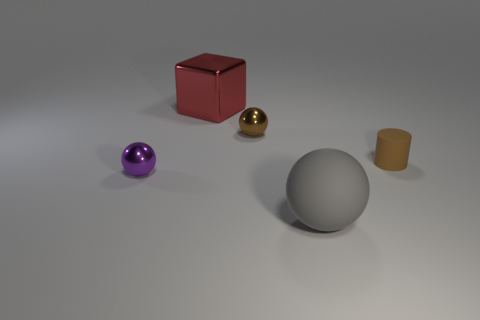There is a small shiny ball to the right of the red cube; does it have the same color as the small rubber object?
Your response must be concise. Yes. Do the cylinder and the small object that is behind the tiny brown cylinder have the same color?
Make the answer very short. Yes. What is the material of the purple sphere that is the same size as the brown cylinder?
Offer a very short reply. Metal. What number of objects are big things left of the brown ball or large brown blocks?
Give a very brief answer. 1. Is the number of large rubber balls right of the gray object the same as the number of large gray things?
Make the answer very short. No. There is a tiny object that is both left of the cylinder and right of the purple metal thing; what is its color?
Ensure brevity in your answer.  Brown. How many spheres are either brown rubber things or matte things?
Offer a terse response. 1. Are there fewer large red cubes in front of the large gray matte ball than tiny green metal spheres?
Your response must be concise. No. What is the shape of the small purple thing that is made of the same material as the big red block?
Keep it short and to the point. Sphere. What number of small matte cylinders have the same color as the large metal cube?
Offer a very short reply. 0. 